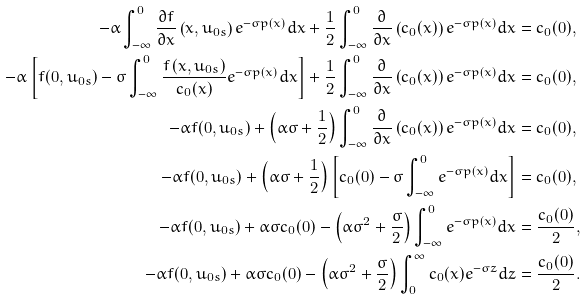Convert formula to latex. <formula><loc_0><loc_0><loc_500><loc_500>- \alpha \int _ { - \infty } ^ { 0 } \frac { \partial f } { \partial x } \left ( x , u _ { 0 s } \right ) e ^ { - \sigma p ( x ) } d x + \frac { 1 } { 2 } \int _ { - \infty } ^ { 0 } \frac { \partial } { \partial x } \left ( c _ { 0 } ( x ) \right ) e ^ { - \sigma p ( x ) } d x & = c _ { 0 } ( 0 ) , \\ - \alpha \left [ f ( 0 , u _ { 0 s } ) - \sigma \int _ { - \infty } ^ { 0 } \frac { f \left ( x , u _ { 0 s } \right ) } { c _ { 0 } ( x ) } e ^ { - \sigma p ( x ) } d x \right ] + \frac { 1 } { 2 } \int _ { - \infty } ^ { 0 } \frac { \partial } { \partial x } \left ( c _ { 0 } ( x ) \right ) e ^ { - \sigma p ( x ) } d x & = c _ { 0 } ( 0 ) , \\ - \alpha f ( 0 , u _ { 0 s } ) + \left ( \alpha \sigma + \frac { 1 } { 2 } \right ) \int _ { - \infty } ^ { 0 } \frac { \partial } { \partial x } \left ( c _ { 0 } ( x ) \right ) e ^ { - \sigma p ( x ) } d x & = c _ { 0 } ( 0 ) , \\ - \alpha f ( 0 , u _ { 0 s } ) + \left ( \alpha \sigma + \frac { 1 } { 2 } \right ) \left [ c _ { 0 } ( 0 ) - \sigma \int _ { - \infty } ^ { 0 } e ^ { - \sigma p ( x ) } d x \right ] & = c _ { 0 } ( 0 ) , \\ - \alpha f ( 0 , u _ { 0 s } ) + \alpha \sigma c _ { 0 } ( 0 ) - \left ( \alpha \sigma ^ { 2 } + \frac { \sigma } { 2 } \right ) \int _ { - \infty } ^ { 0 } e ^ { - \sigma p ( x ) } d x & = \frac { c _ { 0 } ( 0 ) } { 2 } , \\ - \alpha f ( 0 , u _ { 0 s } ) + \alpha \sigma c _ { 0 } ( 0 ) - \left ( \alpha \sigma ^ { 2 } + \frac { \sigma } { 2 } \right ) \int _ { 0 } ^ { \infty } c _ { 0 } ( x ) e ^ { - \sigma z } d z & = \frac { c _ { 0 } ( 0 ) } { 2 } .</formula> 